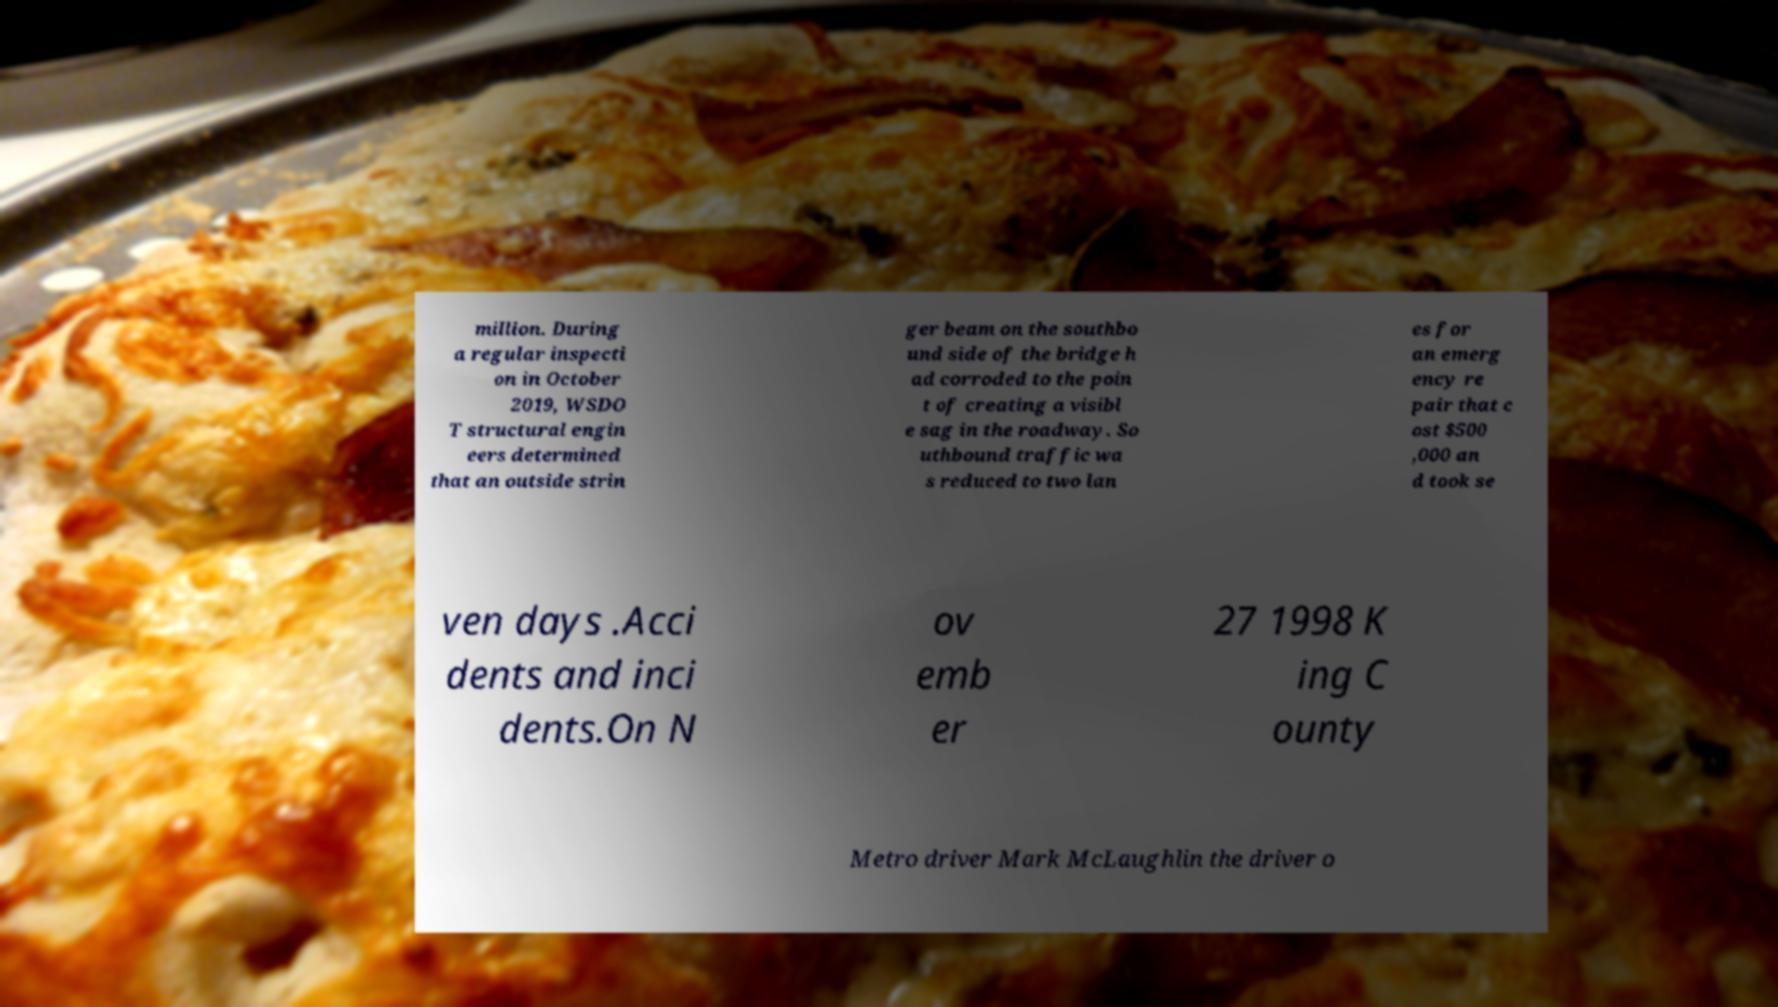Could you extract and type out the text from this image? million. During a regular inspecti on in October 2019, WSDO T structural engin eers determined that an outside strin ger beam on the southbo und side of the bridge h ad corroded to the poin t of creating a visibl e sag in the roadway. So uthbound traffic wa s reduced to two lan es for an emerg ency re pair that c ost $500 ,000 an d took se ven days .Acci dents and inci dents.On N ov emb er 27 1998 K ing C ounty Metro driver Mark McLaughlin the driver o 